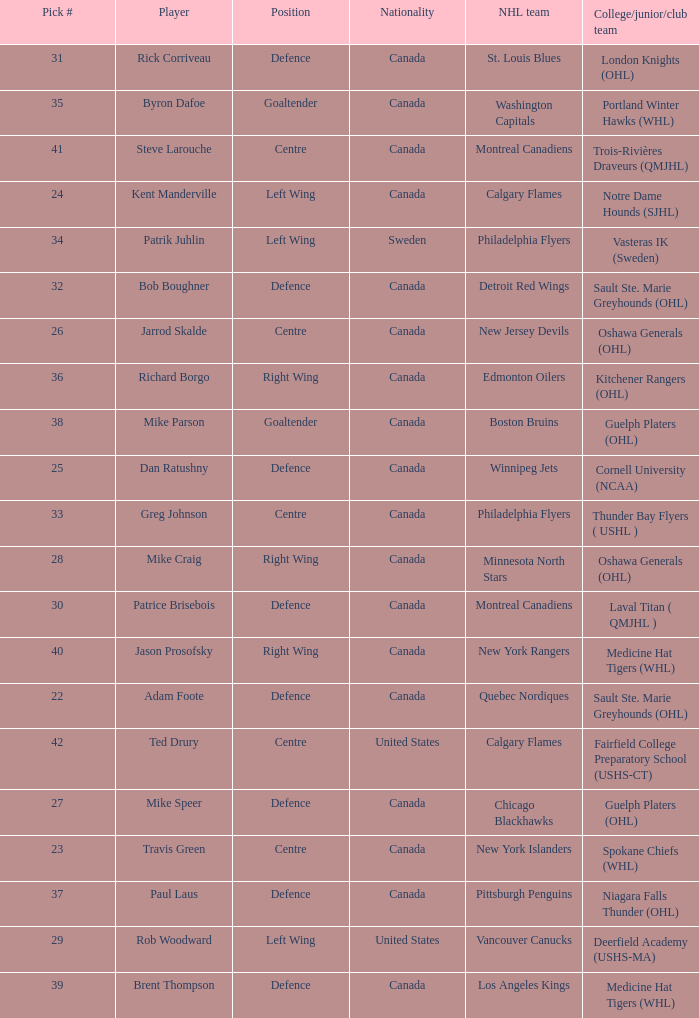What NHL team picked richard borgo? Edmonton Oilers. 